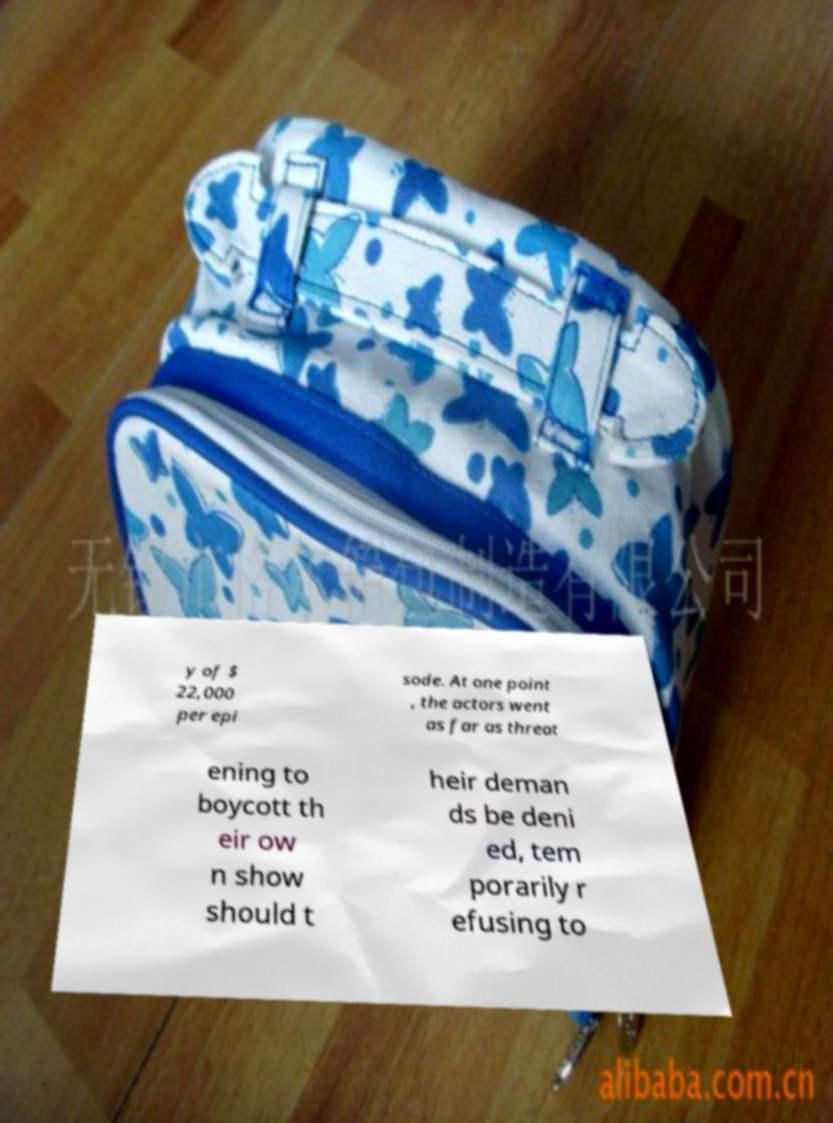Could you assist in decoding the text presented in this image and type it out clearly? y of $ 22,000 per epi sode. At one point , the actors went as far as threat ening to boycott th eir ow n show should t heir deman ds be deni ed, tem porarily r efusing to 